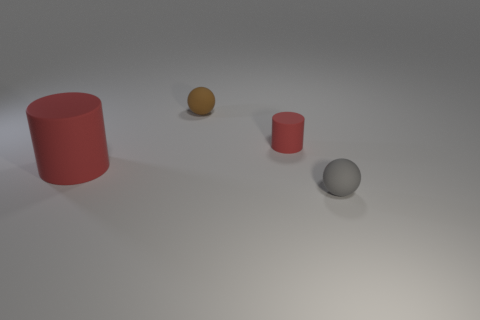Add 2 big objects. How many objects exist? 6 Subtract all tiny things. Subtract all brown rubber balls. How many objects are left? 0 Add 2 rubber spheres. How many rubber spheres are left? 4 Add 1 small red rubber cylinders. How many small red rubber cylinders exist? 2 Subtract 0 green balls. How many objects are left? 4 